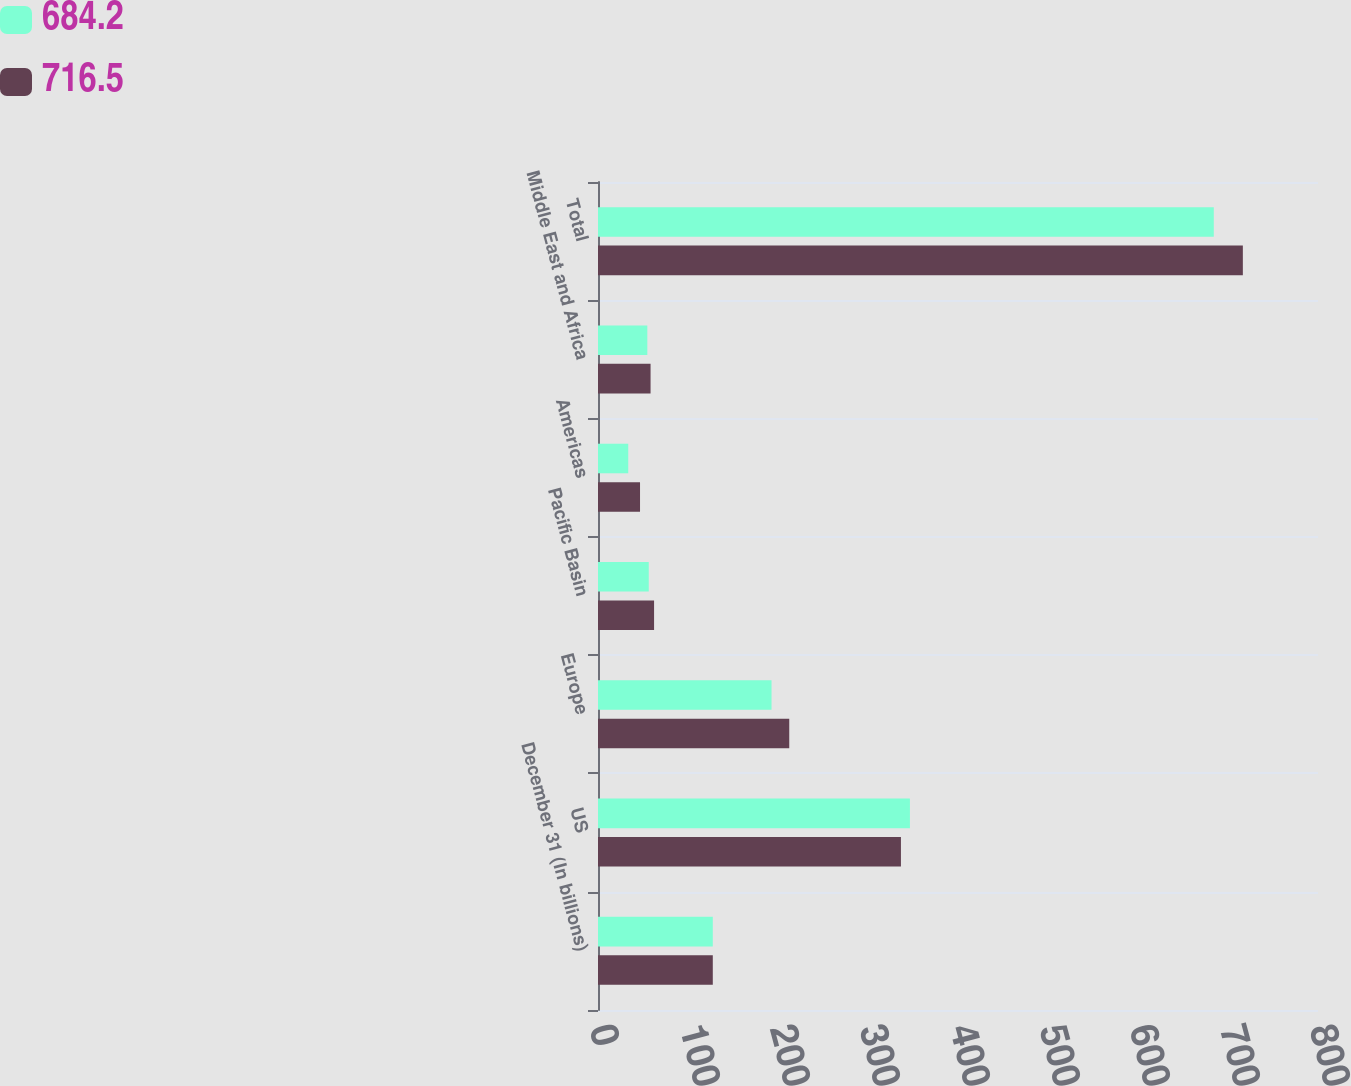Convert chart. <chart><loc_0><loc_0><loc_500><loc_500><stacked_bar_chart><ecel><fcel>December 31 (In billions)<fcel>US<fcel>Europe<fcel>Pacific Basin<fcel>Americas<fcel>Middle East and Africa<fcel>Total<nl><fcel>684.2<fcel>127.55<fcel>346.6<fcel>192.8<fcel>56.4<fcel>33.6<fcel>54.8<fcel>684.2<nl><fcel>716.5<fcel>127.55<fcel>336.6<fcel>212.5<fcel>62.3<fcel>46.7<fcel>58.4<fcel>716.5<nl></chart> 